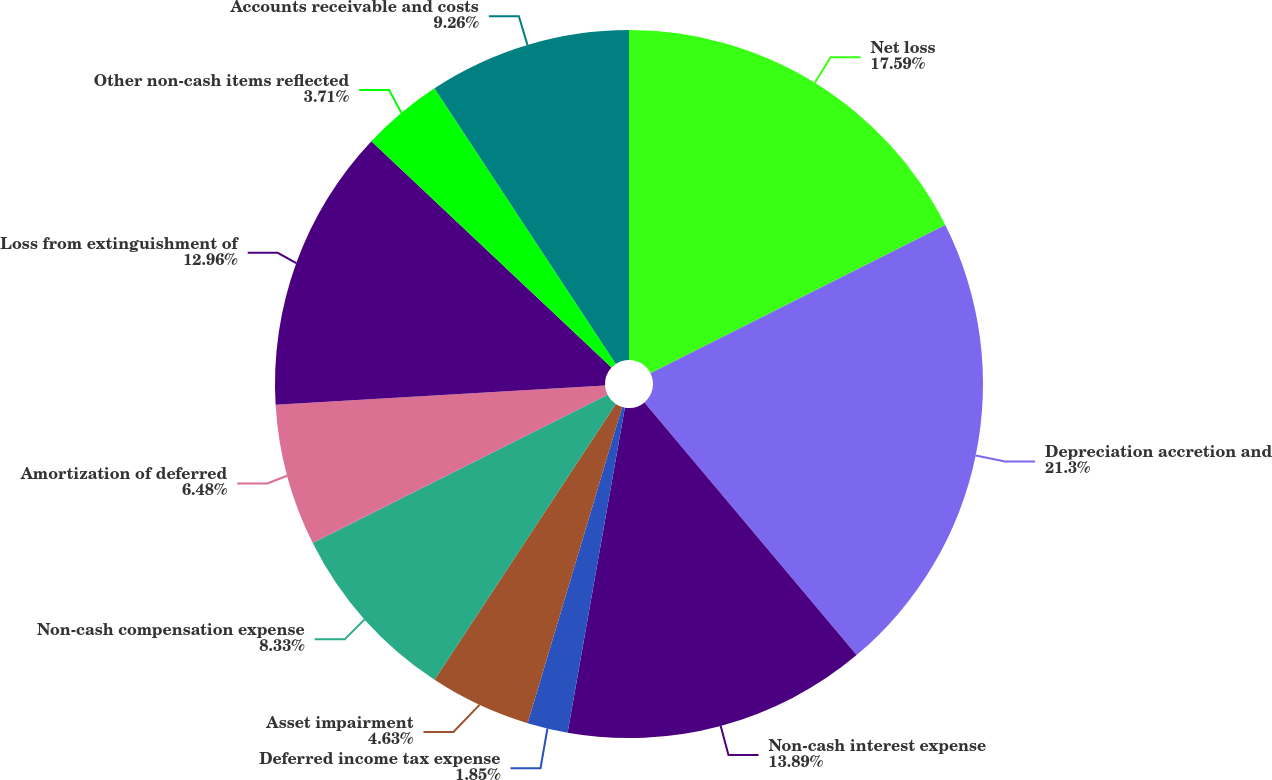Convert chart. <chart><loc_0><loc_0><loc_500><loc_500><pie_chart><fcel>Net loss<fcel>Depreciation accretion and<fcel>Non-cash interest expense<fcel>Deferred income tax expense<fcel>Asset impairment<fcel>Non-cash compensation expense<fcel>Amortization of deferred<fcel>Loss from extinguishment of<fcel>Other non-cash items reflected<fcel>Accounts receivable and costs<nl><fcel>17.59%<fcel>21.29%<fcel>13.89%<fcel>1.85%<fcel>4.63%<fcel>8.33%<fcel>6.48%<fcel>12.96%<fcel>3.71%<fcel>9.26%<nl></chart> 